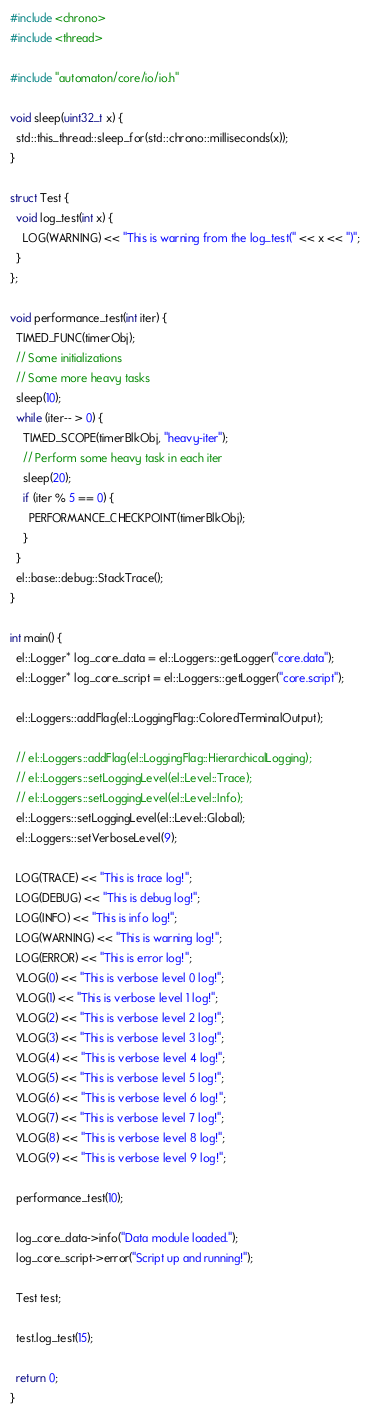Convert code to text. <code><loc_0><loc_0><loc_500><loc_500><_C++_>#include <chrono>
#include <thread>

#include "automaton/core/io/io.h"

void sleep(uint32_t x) {
  std::this_thread::sleep_for(std::chrono::milliseconds(x));
}

struct Test {
  void log_test(int x) {
    LOG(WARNING) << "This is warning from the log_test(" << x << ")";
  }
};

void performance_test(int iter) {
  TIMED_FUNC(timerObj);
  // Some initializations
  // Some more heavy tasks
  sleep(10);
  while (iter-- > 0) {
    TIMED_SCOPE(timerBlkObj, "heavy-iter");
    // Perform some heavy task in each iter
    sleep(20);
    if (iter % 5 == 0) {
      PERFORMANCE_CHECKPOINT(timerBlkObj);
    }
  }
  el::base::debug::StackTrace();
}

int main() {
  el::Logger* log_core_data = el::Loggers::getLogger("core.data");
  el::Logger* log_core_script = el::Loggers::getLogger("core.script");

  el::Loggers::addFlag(el::LoggingFlag::ColoredTerminalOutput);

  // el::Loggers::addFlag(el::LoggingFlag::HierarchicalLogging);
  // el::Loggers::setLoggingLevel(el::Level::Trace);
  // el::Loggers::setLoggingLevel(el::Level::Info);
  el::Loggers::setLoggingLevel(el::Level::Global);
  el::Loggers::setVerboseLevel(9);

  LOG(TRACE) << "This is trace log!";
  LOG(DEBUG) << "This is debug log!";
  LOG(INFO) << "This is info log!";
  LOG(WARNING) << "This is warning log!";
  LOG(ERROR) << "This is error log!";
  VLOG(0) << "This is verbose level 0 log!";
  VLOG(1) << "This is verbose level 1 log!";
  VLOG(2) << "This is verbose level 2 log!";
  VLOG(3) << "This is verbose level 3 log!";
  VLOG(4) << "This is verbose level 4 log!";
  VLOG(5) << "This is verbose level 5 log!";
  VLOG(6) << "This is verbose level 6 log!";
  VLOG(7) << "This is verbose level 7 log!";
  VLOG(8) << "This is verbose level 8 log!";
  VLOG(9) << "This is verbose level 9 log!";

  performance_test(10);

  log_core_data->info("Data module loaded.");
  log_core_script->error("Script up and running!");

  Test test;

  test.log_test(15);

  return 0;
}
</code> 